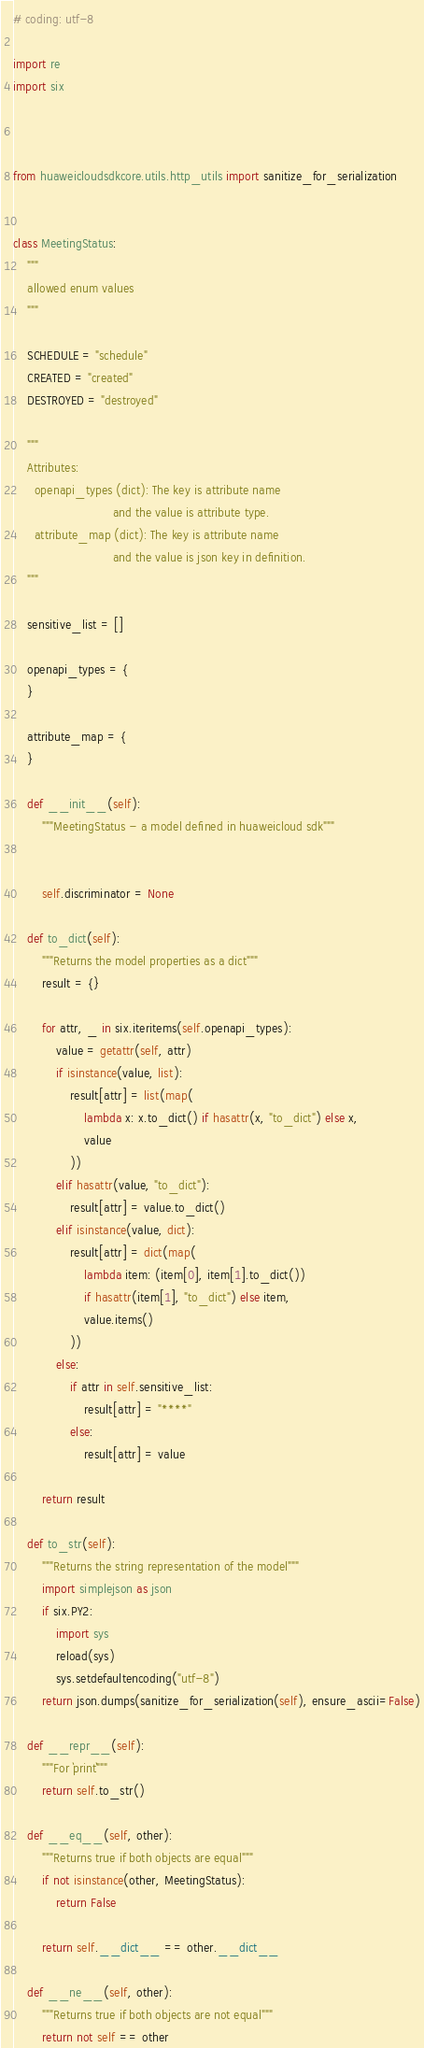Convert code to text. <code><loc_0><loc_0><loc_500><loc_500><_Python_># coding: utf-8

import re
import six



from huaweicloudsdkcore.utils.http_utils import sanitize_for_serialization


class MeetingStatus:
    """
    allowed enum values
    """

    SCHEDULE = "schedule"
    CREATED = "created"
    DESTROYED = "destroyed"

    """
    Attributes:
      openapi_types (dict): The key is attribute name
                            and the value is attribute type.
      attribute_map (dict): The key is attribute name
                            and the value is json key in definition.
    """

    sensitive_list = []

    openapi_types = {
    }

    attribute_map = {
    }

    def __init__(self):
        """MeetingStatus - a model defined in huaweicloud sdk"""
        
        
        self.discriminator = None

    def to_dict(self):
        """Returns the model properties as a dict"""
        result = {}

        for attr, _ in six.iteritems(self.openapi_types):
            value = getattr(self, attr)
            if isinstance(value, list):
                result[attr] = list(map(
                    lambda x: x.to_dict() if hasattr(x, "to_dict") else x,
                    value
                ))
            elif hasattr(value, "to_dict"):
                result[attr] = value.to_dict()
            elif isinstance(value, dict):
                result[attr] = dict(map(
                    lambda item: (item[0], item[1].to_dict())
                    if hasattr(item[1], "to_dict") else item,
                    value.items()
                ))
            else:
                if attr in self.sensitive_list:
                    result[attr] = "****"
                else:
                    result[attr] = value

        return result

    def to_str(self):
        """Returns the string representation of the model"""
        import simplejson as json
        if six.PY2:
            import sys
            reload(sys)
            sys.setdefaultencoding("utf-8")
        return json.dumps(sanitize_for_serialization(self), ensure_ascii=False)

    def __repr__(self):
        """For `print`"""
        return self.to_str()

    def __eq__(self, other):
        """Returns true if both objects are equal"""
        if not isinstance(other, MeetingStatus):
            return False

        return self.__dict__ == other.__dict__

    def __ne__(self, other):
        """Returns true if both objects are not equal"""
        return not self == other
</code> 